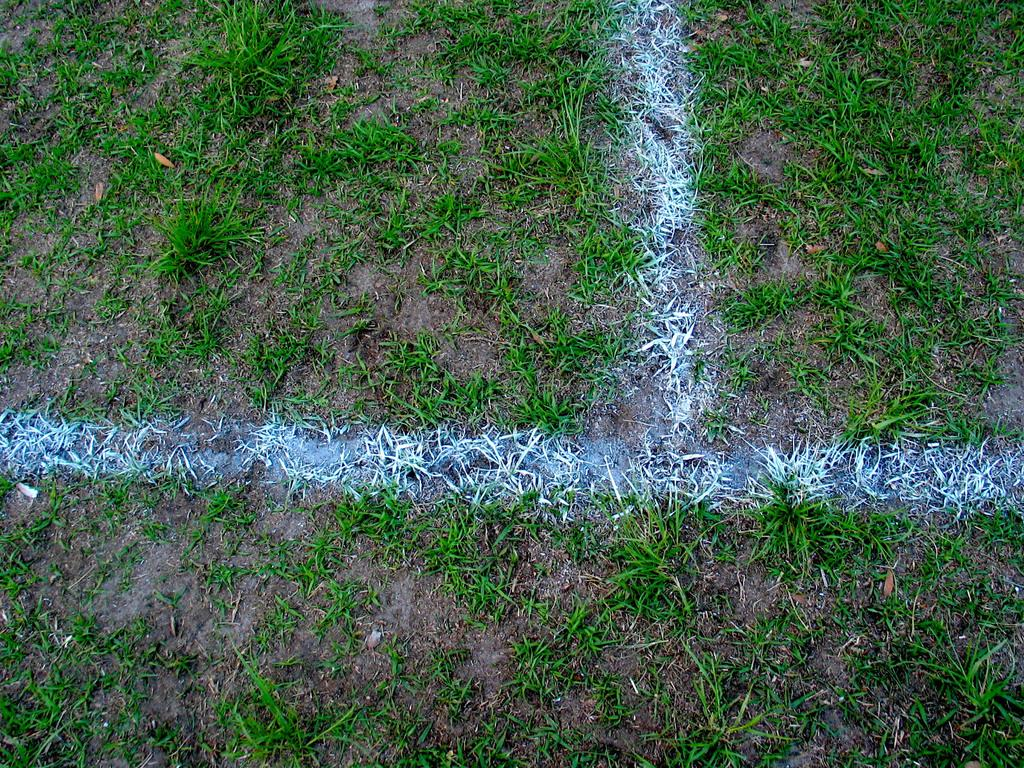What color is the powder that is on the grass in the image? The powder on the grass is white. What type of surface is visible in the image? There is grass visible in the image. What is present at the bottom of the image? There is mud at the bottom of the image. What type of juice is being squeezed out of the brain in the image? There is no brain or juice present in the image; it only features white powder on the grass and mud at the bottom. 